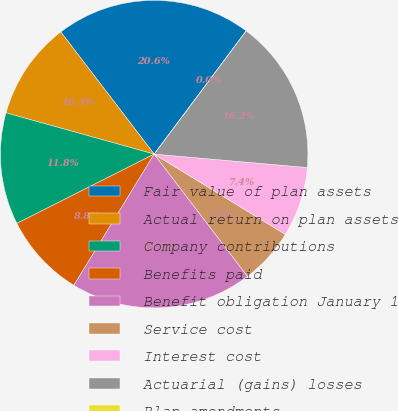Convert chart to OTSL. <chart><loc_0><loc_0><loc_500><loc_500><pie_chart><fcel>Fair value of plan assets<fcel>Actual return on plan assets<fcel>Company contributions<fcel>Benefits paid<fcel>Benefit obligation January 1<fcel>Service cost<fcel>Interest cost<fcel>Actuarial (gains) losses<fcel>Plan amendments<nl><fcel>20.59%<fcel>10.29%<fcel>11.76%<fcel>8.82%<fcel>19.12%<fcel>5.88%<fcel>7.35%<fcel>16.18%<fcel>0.0%<nl></chart> 